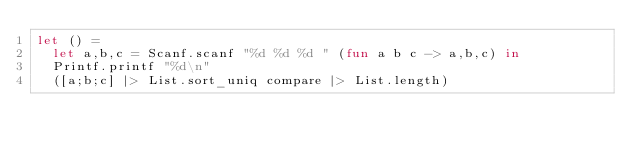<code> <loc_0><loc_0><loc_500><loc_500><_OCaml_>let () =
  let a,b,c = Scanf.scanf "%d %d %d " (fun a b c -> a,b,c) in
  Printf.printf "%d\n" 
  ([a;b;c] |> List.sort_uniq compare |> List.length)
</code> 